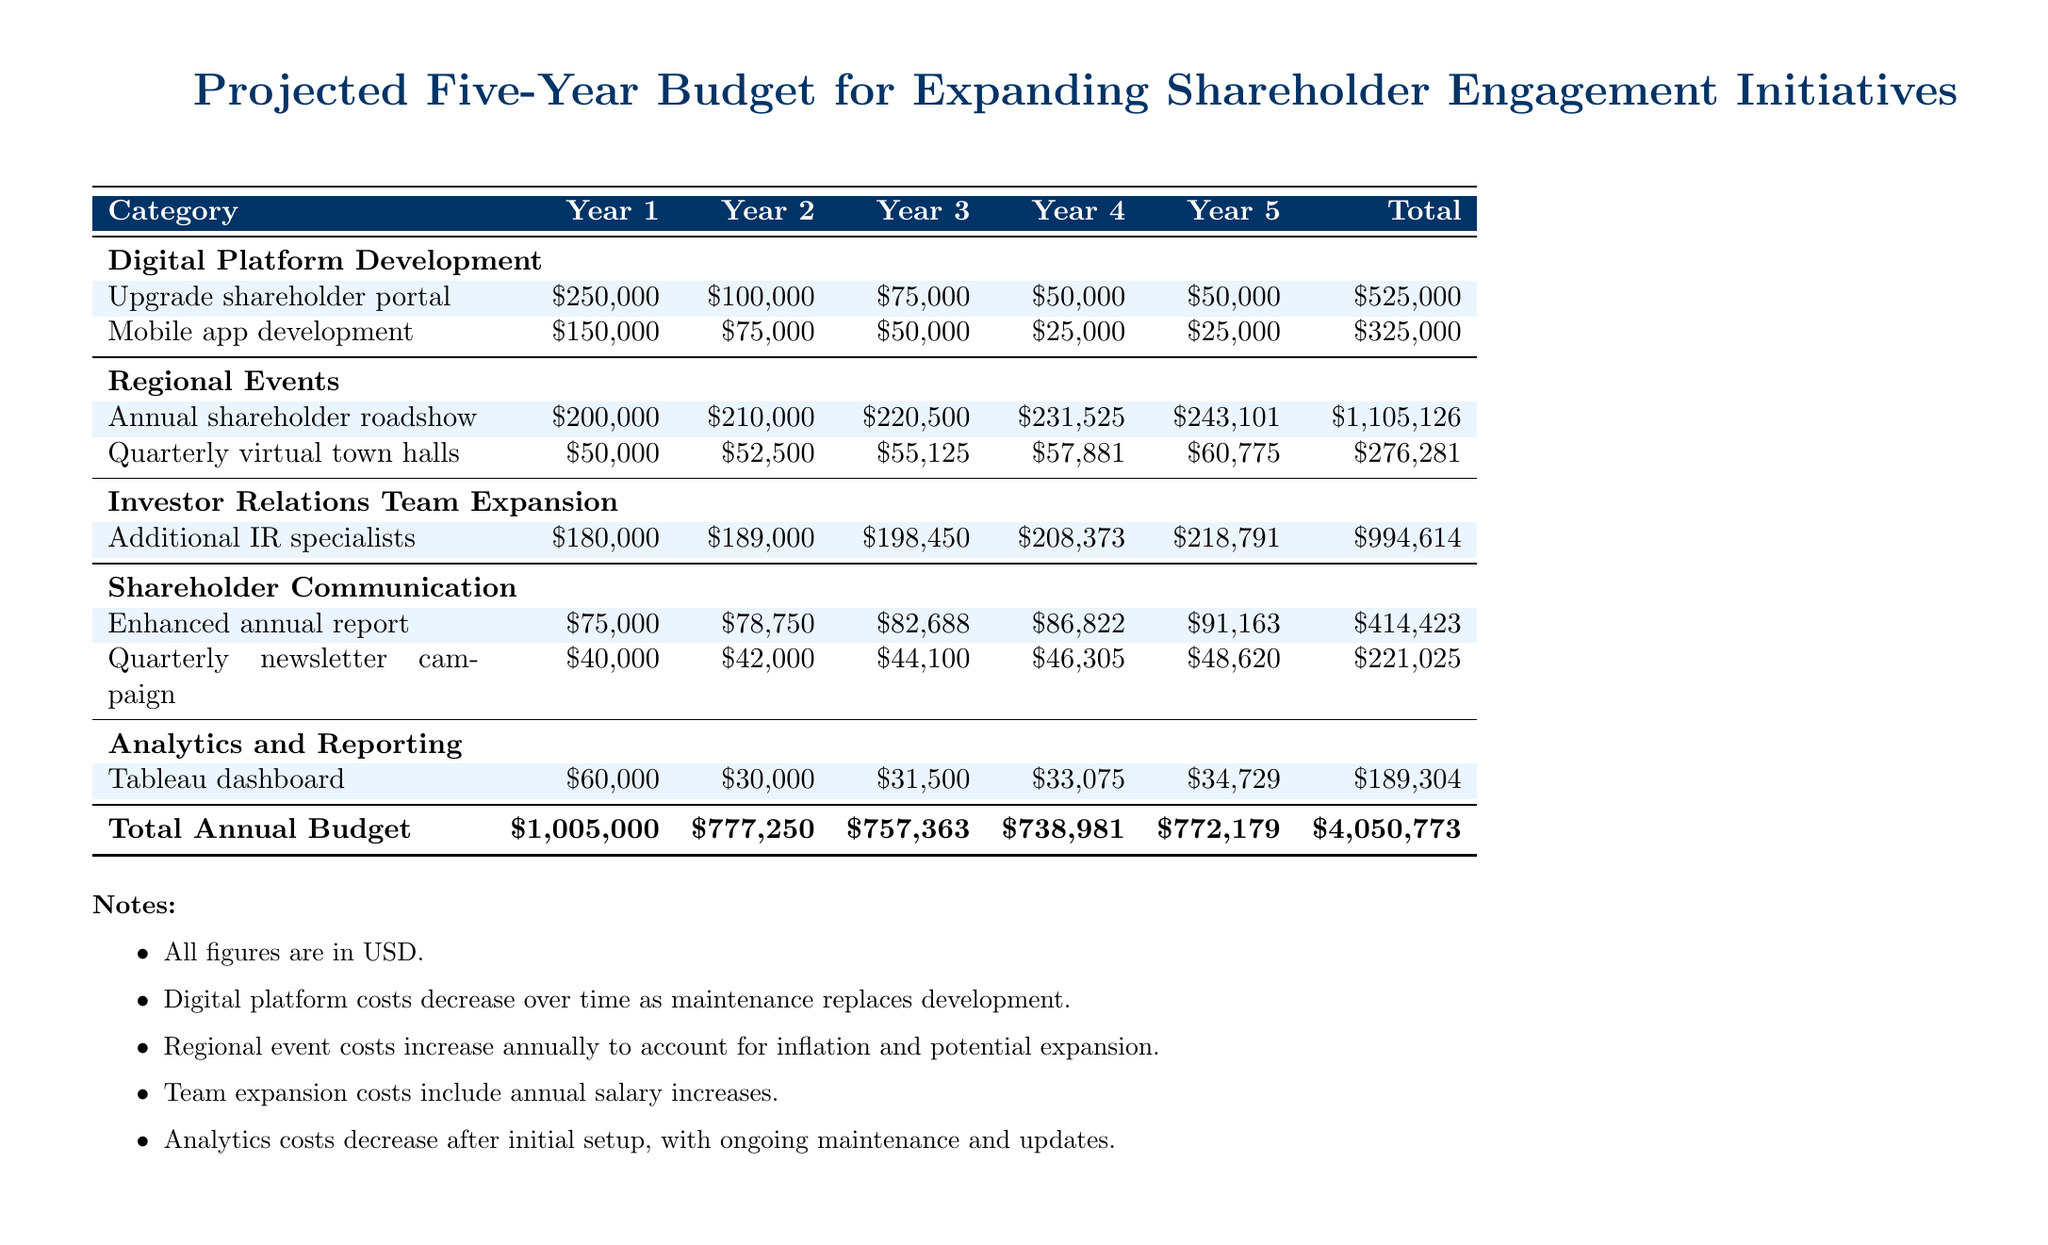What is the total budget for Year 1? The total budget for Year 1 is the sum of all categories listed for that year, which amounts to one million five thousand dollars.
Answer: One million five thousand dollars How much is allocated for the mobile app development in Year 3? The amount allocated for the mobile app development in Year 3 is specified in the budget table under that category for Year 3.
Answer: Fifty thousand dollars What is the total investment in regional events over five years? The total investment in regional events is calculated by summing the amounts from the annual shareholder roadshow and quarterly virtual town halls for all five years.
Answer: One million three hundred eighty-one thousand four hundred seven dollars What was the budget for additional IR specialists in Year 4? This amount can be found by referencing the category of Investor Relations Team Expansion for Year 4 in the budget.
Answer: Two hundred eight thousand three hundred seventy-three dollars Which category has the largest total budget over five years? The category with the largest total budget is identified by reviewing the total for each category listed in the document.
Answer: Regional Events What are the projected costs for Tableau dashboard in Year 2? The costs for Tableau dashboard in Year 2 can be retrieved by checking the Analytics and Reporting section for that year.
Answer: Thirty thousand dollars What is the annual increase percentage for the annual shareholder roadshow from Year 1 to Year 2? This percentage can be calculated using the difference between Year 1 and Year 2 costs divided by Year 1 cost, expressed as a percentage.
Answer: Five percent How much is allocated for the enhanced annual report over the five-year period? This total is found by summing all the amounts listed for the enhanced annual report from Year 1 to Year 5.
Answer: Four hundred fourteen thousand four hundred twenty-three dollars What notes are provided regarding the digital platform costs? The notes accompanying the budget document give insights about how costs are handled, specifically concerning digital platform expenses.
Answer: Decrease over time as maintenance replaces development 